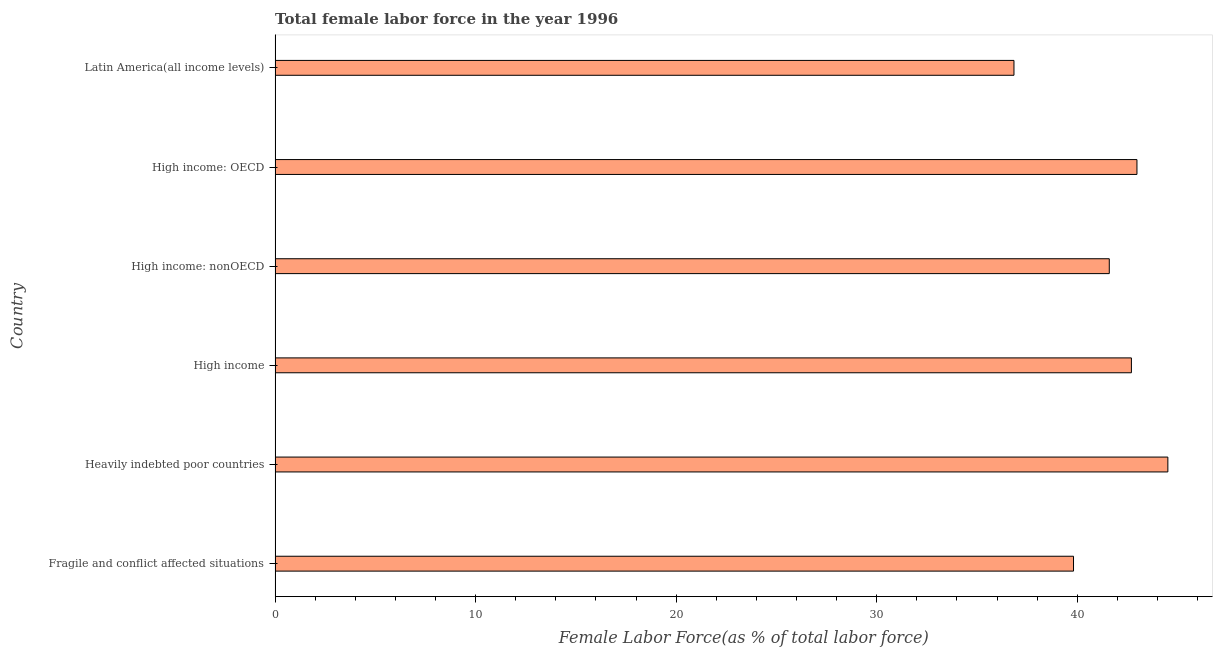What is the title of the graph?
Your response must be concise. Total female labor force in the year 1996. What is the label or title of the X-axis?
Provide a succinct answer. Female Labor Force(as % of total labor force). What is the total female labor force in High income: OECD?
Your response must be concise. 42.98. Across all countries, what is the maximum total female labor force?
Offer a very short reply. 44.52. Across all countries, what is the minimum total female labor force?
Keep it short and to the point. 36.85. In which country was the total female labor force maximum?
Ensure brevity in your answer.  Heavily indebted poor countries. In which country was the total female labor force minimum?
Your response must be concise. Latin America(all income levels). What is the sum of the total female labor force?
Offer a terse response. 248.46. What is the difference between the total female labor force in Heavily indebted poor countries and High income?
Provide a short and direct response. 1.82. What is the average total female labor force per country?
Your answer should be very brief. 41.41. What is the median total female labor force?
Ensure brevity in your answer.  42.15. Is the total female labor force in High income less than that in Latin America(all income levels)?
Your response must be concise. No. What is the difference between the highest and the second highest total female labor force?
Offer a terse response. 1.54. Is the sum of the total female labor force in Heavily indebted poor countries and High income: OECD greater than the maximum total female labor force across all countries?
Offer a terse response. Yes. What is the difference between the highest and the lowest total female labor force?
Offer a very short reply. 7.67. In how many countries, is the total female labor force greater than the average total female labor force taken over all countries?
Ensure brevity in your answer.  4. How many countries are there in the graph?
Keep it short and to the point. 6. What is the difference between two consecutive major ticks on the X-axis?
Offer a terse response. 10. Are the values on the major ticks of X-axis written in scientific E-notation?
Your answer should be very brief. No. What is the Female Labor Force(as % of total labor force) of Fragile and conflict affected situations?
Your answer should be very brief. 39.81. What is the Female Labor Force(as % of total labor force) of Heavily indebted poor countries?
Make the answer very short. 44.52. What is the Female Labor Force(as % of total labor force) in High income?
Provide a short and direct response. 42.7. What is the Female Labor Force(as % of total labor force) of High income: nonOECD?
Give a very brief answer. 41.6. What is the Female Labor Force(as % of total labor force) in High income: OECD?
Give a very brief answer. 42.98. What is the Female Labor Force(as % of total labor force) in Latin America(all income levels)?
Your answer should be very brief. 36.85. What is the difference between the Female Labor Force(as % of total labor force) in Fragile and conflict affected situations and Heavily indebted poor countries?
Ensure brevity in your answer.  -4.7. What is the difference between the Female Labor Force(as % of total labor force) in Fragile and conflict affected situations and High income?
Keep it short and to the point. -2.89. What is the difference between the Female Labor Force(as % of total labor force) in Fragile and conflict affected situations and High income: nonOECD?
Make the answer very short. -1.78. What is the difference between the Female Labor Force(as % of total labor force) in Fragile and conflict affected situations and High income: OECD?
Provide a succinct answer. -3.16. What is the difference between the Female Labor Force(as % of total labor force) in Fragile and conflict affected situations and Latin America(all income levels)?
Provide a succinct answer. 2.97. What is the difference between the Female Labor Force(as % of total labor force) in Heavily indebted poor countries and High income?
Your answer should be very brief. 1.82. What is the difference between the Female Labor Force(as % of total labor force) in Heavily indebted poor countries and High income: nonOECD?
Give a very brief answer. 2.92. What is the difference between the Female Labor Force(as % of total labor force) in Heavily indebted poor countries and High income: OECD?
Your answer should be very brief. 1.54. What is the difference between the Female Labor Force(as % of total labor force) in Heavily indebted poor countries and Latin America(all income levels)?
Your answer should be very brief. 7.67. What is the difference between the Female Labor Force(as % of total labor force) in High income and High income: nonOECD?
Your response must be concise. 1.1. What is the difference between the Female Labor Force(as % of total labor force) in High income and High income: OECD?
Ensure brevity in your answer.  -0.28. What is the difference between the Female Labor Force(as % of total labor force) in High income and Latin America(all income levels)?
Offer a terse response. 5.86. What is the difference between the Female Labor Force(as % of total labor force) in High income: nonOECD and High income: OECD?
Ensure brevity in your answer.  -1.38. What is the difference between the Female Labor Force(as % of total labor force) in High income: nonOECD and Latin America(all income levels)?
Your answer should be very brief. 4.75. What is the difference between the Female Labor Force(as % of total labor force) in High income: OECD and Latin America(all income levels)?
Provide a succinct answer. 6.13. What is the ratio of the Female Labor Force(as % of total labor force) in Fragile and conflict affected situations to that in Heavily indebted poor countries?
Keep it short and to the point. 0.89. What is the ratio of the Female Labor Force(as % of total labor force) in Fragile and conflict affected situations to that in High income?
Offer a terse response. 0.93. What is the ratio of the Female Labor Force(as % of total labor force) in Fragile and conflict affected situations to that in High income: nonOECD?
Ensure brevity in your answer.  0.96. What is the ratio of the Female Labor Force(as % of total labor force) in Fragile and conflict affected situations to that in High income: OECD?
Your response must be concise. 0.93. What is the ratio of the Female Labor Force(as % of total labor force) in Fragile and conflict affected situations to that in Latin America(all income levels)?
Your answer should be very brief. 1.08. What is the ratio of the Female Labor Force(as % of total labor force) in Heavily indebted poor countries to that in High income?
Your answer should be compact. 1.04. What is the ratio of the Female Labor Force(as % of total labor force) in Heavily indebted poor countries to that in High income: nonOECD?
Provide a short and direct response. 1.07. What is the ratio of the Female Labor Force(as % of total labor force) in Heavily indebted poor countries to that in High income: OECD?
Ensure brevity in your answer.  1.04. What is the ratio of the Female Labor Force(as % of total labor force) in Heavily indebted poor countries to that in Latin America(all income levels)?
Provide a succinct answer. 1.21. What is the ratio of the Female Labor Force(as % of total labor force) in High income to that in Latin America(all income levels)?
Your answer should be very brief. 1.16. What is the ratio of the Female Labor Force(as % of total labor force) in High income: nonOECD to that in High income: OECD?
Ensure brevity in your answer.  0.97. What is the ratio of the Female Labor Force(as % of total labor force) in High income: nonOECD to that in Latin America(all income levels)?
Your answer should be very brief. 1.13. What is the ratio of the Female Labor Force(as % of total labor force) in High income: OECD to that in Latin America(all income levels)?
Offer a terse response. 1.17. 